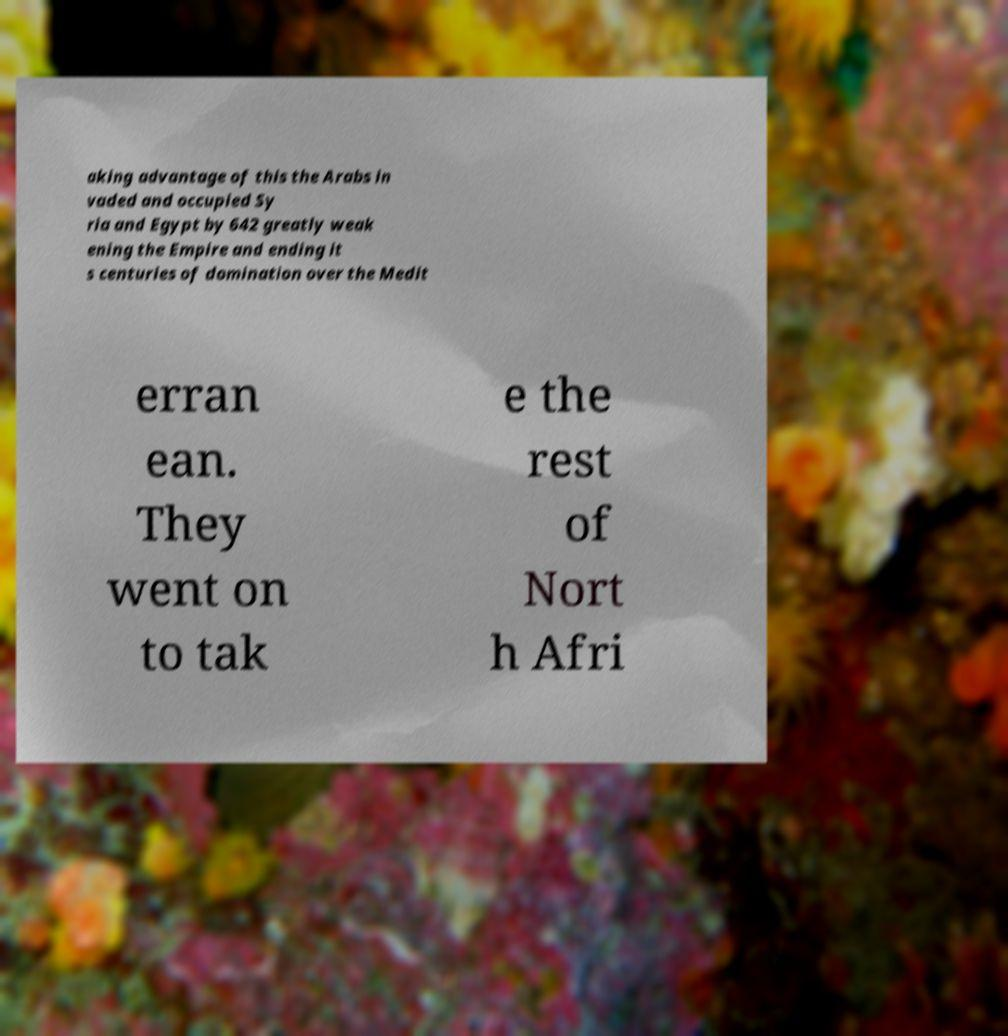There's text embedded in this image that I need extracted. Can you transcribe it verbatim? aking advantage of this the Arabs in vaded and occupied Sy ria and Egypt by 642 greatly weak ening the Empire and ending it s centuries of domination over the Medit erran ean. They went on to tak e the rest of Nort h Afri 